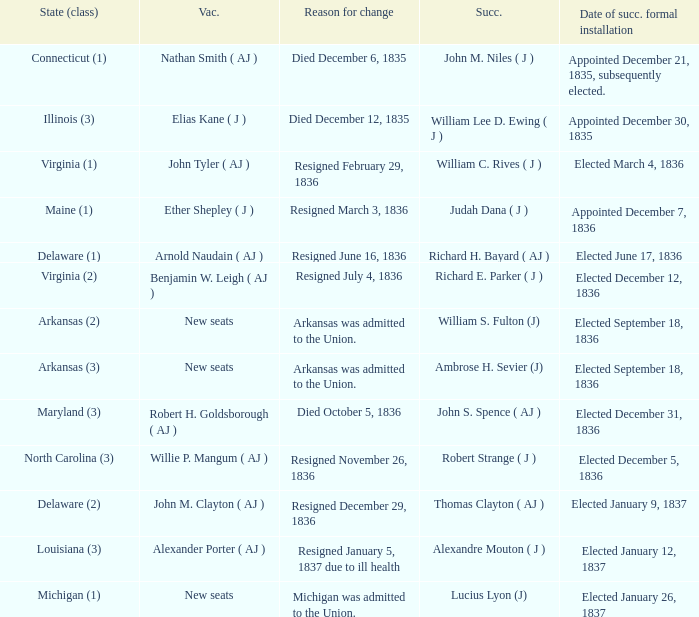Name the successor for elected january 26, 1837 1.0. 